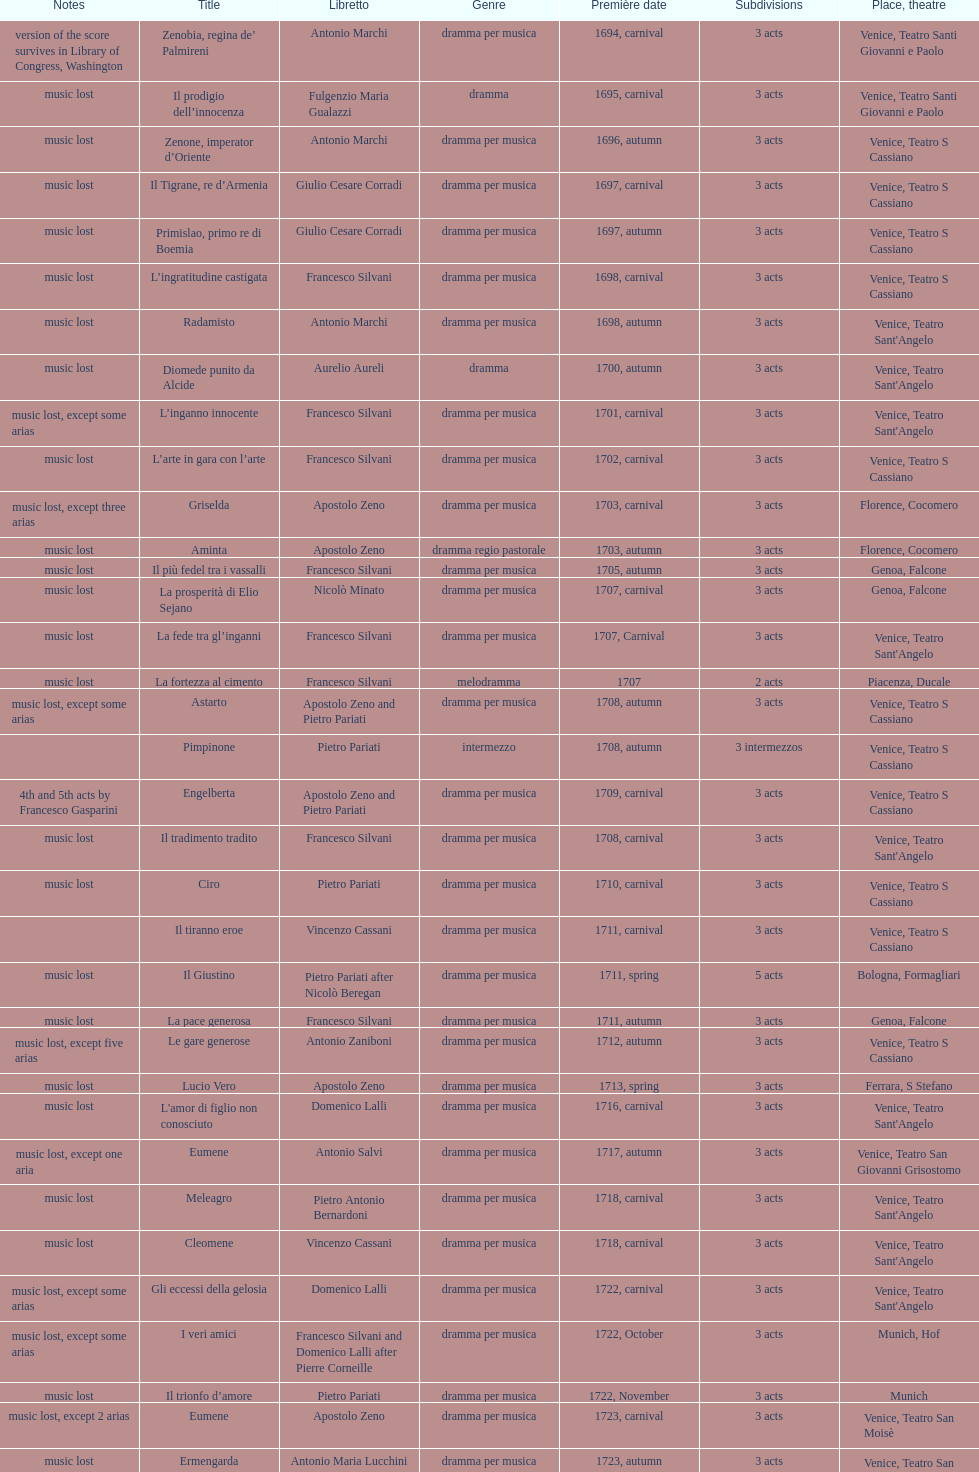I'm looking to parse the entire table for insights. Could you assist me with that? {'header': ['Notes', 'Title', 'Libretto', 'Genre', 'Première date', 'Sub\xaddivisions', 'Place, theatre'], 'rows': [['version of the score survives in Library of Congress, Washington', 'Zenobia, regina de’ Palmireni', 'Antonio Marchi', 'dramma per musica', '1694, carnival', '3 acts', 'Venice, Teatro Santi Giovanni e Paolo'], ['music lost', 'Il prodigio dell’innocenza', 'Fulgenzio Maria Gualazzi', 'dramma', '1695, carnival', '3 acts', 'Venice, Teatro Santi Giovanni e Paolo'], ['music lost', 'Zenone, imperator d’Oriente', 'Antonio Marchi', 'dramma per musica', '1696, autumn', '3 acts', 'Venice, Teatro S Cassiano'], ['music lost', 'Il Tigrane, re d’Armenia', 'Giulio Cesare Corradi', 'dramma per musica', '1697, carnival', '3 acts', 'Venice, Teatro S Cassiano'], ['music lost', 'Primislao, primo re di Boemia', 'Giulio Cesare Corradi', 'dramma per musica', '1697, autumn', '3 acts', 'Venice, Teatro S Cassiano'], ['music lost', 'L’ingratitudine castigata', 'Francesco Silvani', 'dramma per musica', '1698, carnival', '3 acts', 'Venice, Teatro S Cassiano'], ['music lost', 'Radamisto', 'Antonio Marchi', 'dramma per musica', '1698, autumn', '3 acts', "Venice, Teatro Sant'Angelo"], ['music lost', 'Diomede punito da Alcide', 'Aurelio Aureli', 'dramma', '1700, autumn', '3 acts', "Venice, Teatro Sant'Angelo"], ['music lost, except some arias', 'L’inganno innocente', 'Francesco Silvani', 'dramma per musica', '1701, carnival', '3 acts', "Venice, Teatro Sant'Angelo"], ['music lost', 'L’arte in gara con l’arte', 'Francesco Silvani', 'dramma per musica', '1702, carnival', '3 acts', 'Venice, Teatro S Cassiano'], ['music lost, except three arias', 'Griselda', 'Apostolo Zeno', 'dramma per musica', '1703, carnival', '3 acts', 'Florence, Cocomero'], ['music lost', 'Aminta', 'Apostolo Zeno', 'dramma regio pastorale', '1703, autumn', '3 acts', 'Florence, Cocomero'], ['music lost', 'Il più fedel tra i vassalli', 'Francesco Silvani', 'dramma per musica', '1705, autumn', '3 acts', 'Genoa, Falcone'], ['music lost', 'La prosperità di Elio Sejano', 'Nicolò Minato', 'dramma per musica', '1707, carnival', '3 acts', 'Genoa, Falcone'], ['music lost', 'La fede tra gl’inganni', 'Francesco Silvani', 'dramma per musica', '1707, Carnival', '3 acts', "Venice, Teatro Sant'Angelo"], ['music lost', 'La fortezza al cimento', 'Francesco Silvani', 'melodramma', '1707', '2 acts', 'Piacenza, Ducale'], ['music lost, except some arias', 'Astarto', 'Apostolo Zeno and Pietro Pariati', 'dramma per musica', '1708, autumn', '3 acts', 'Venice, Teatro S Cassiano'], ['', 'Pimpinone', 'Pietro Pariati', 'intermezzo', '1708, autumn', '3 intermezzos', 'Venice, Teatro S Cassiano'], ['4th and 5th acts by Francesco Gasparini', 'Engelberta', 'Apostolo Zeno and Pietro Pariati', 'dramma per musica', '1709, carnival', '3 acts', 'Venice, Teatro S Cassiano'], ['music lost', 'Il tradimento tradito', 'Francesco Silvani', 'dramma per musica', '1708, carnival', '3 acts', "Venice, Teatro Sant'Angelo"], ['music lost', 'Ciro', 'Pietro Pariati', 'dramma per musica', '1710, carnival', '3 acts', 'Venice, Teatro S Cassiano'], ['', 'Il tiranno eroe', 'Vincenzo Cassani', 'dramma per musica', '1711, carnival', '3 acts', 'Venice, Teatro S Cassiano'], ['music lost', 'Il Giustino', 'Pietro Pariati after Nicolò Beregan', 'dramma per musica', '1711, spring', '5 acts', 'Bologna, Formagliari'], ['music lost', 'La pace generosa', 'Francesco Silvani', 'dramma per musica', '1711, autumn', '3 acts', 'Genoa, Falcone'], ['music lost, except five arias', 'Le gare generose', 'Antonio Zaniboni', 'dramma per musica', '1712, autumn', '3 acts', 'Venice, Teatro S Cassiano'], ['music lost', 'Lucio Vero', 'Apostolo Zeno', 'dramma per musica', '1713, spring', '3 acts', 'Ferrara, S Stefano'], ['music lost', "L'amor di figlio non conosciuto", 'Domenico Lalli', 'dramma per musica', '1716, carnival', '3 acts', "Venice, Teatro Sant'Angelo"], ['music lost, except one aria', 'Eumene', 'Antonio Salvi', 'dramma per musica', '1717, autumn', '3 acts', 'Venice, Teatro San Giovanni Grisostomo'], ['music lost', 'Meleagro', 'Pietro Antonio Bernardoni', 'dramma per musica', '1718, carnival', '3 acts', "Venice, Teatro Sant'Angelo"], ['music lost', 'Cleomene', 'Vincenzo Cassani', 'dramma per musica', '1718, carnival', '3 acts', "Venice, Teatro Sant'Angelo"], ['music lost, except some arias', 'Gli eccessi della gelosia', 'Domenico Lalli', 'dramma per musica', '1722, carnival', '3 acts', "Venice, Teatro Sant'Angelo"], ['music lost, except some arias', 'I veri amici', 'Francesco Silvani and Domenico Lalli after Pierre Corneille', 'dramma per musica', '1722, October', '3 acts', 'Munich, Hof'], ['music lost', 'Il trionfo d’amore', 'Pietro Pariati', 'dramma per musica', '1722, November', '3 acts', 'Munich'], ['music lost, except 2 arias', 'Eumene', 'Apostolo Zeno', 'dramma per musica', '1723, carnival', '3 acts', 'Venice, Teatro San Moisè'], ['music lost', 'Ermengarda', 'Antonio Maria Lucchini', 'dramma per musica', '1723, autumn', '3 acts', 'Venice, Teatro San Moisè'], ['5th act by Giovanni Porta, music lost', 'Antigono, tutore di Filippo, re di Macedonia', 'Giovanni Piazzon', 'tragedia', '1724, carnival', '5 acts', 'Venice, Teatro San Moisè'], ['music lost', 'Scipione nelle Spagne', 'Apostolo Zeno', 'dramma per musica', '1724, Ascension', '3 acts', 'Venice, Teatro San Samuele'], ['music lost, except 2 arias', 'Laodice', 'Angelo Schietti', 'dramma per musica', '1724, autumn', '3 acts', 'Venice, Teatro San Moisè'], ['music lost', 'Didone abbandonata', 'Metastasio', 'tragedia', '1725, carnival', '3 acts', 'Venice, Teatro S Cassiano'], ['music lost', "L'impresario delle Isole Canarie", 'Metastasio', 'intermezzo', '1725, carnival', '2 acts', 'Venice, Teatro S Cassiano'], ['music lost', 'Alcina delusa da Ruggero', 'Antonio Marchi', 'dramma per musica', '1725, autumn', '3 acts', 'Venice, Teatro S Cassiano'], ['', 'I rivali generosi', 'Apostolo Zeno', 'dramma per musica', '1725', '3 acts', 'Brescia, Nuovo'], ['', 'La Statira', 'Apostolo Zeno and Pietro Pariati', 'dramma per musica', '1726, Carnival', '3 acts', 'Rome, Teatro Capranica'], ['', 'Malsazio e Fiammetta', '', 'intermezzo', '1726, Carnival', '', 'Rome, Teatro Capranica'], ['music lost', 'Il trionfo di Armida', 'Girolamo Colatelli after Torquato Tasso', 'dramma per musica', '1726, autumn', '3 acts', 'Venice, Teatro San Moisè'], ['music lost, except some arias', 'L’incostanza schernita', 'Vincenzo Cassani', 'dramma comico-pastorale', '1727, Ascension', '3 acts', 'Venice, Teatro San Samuele'], ['music lost', 'Le due rivali in amore', 'Aurelio Aureli', 'dramma per musica', '1728, autumn', '3 acts', 'Venice, Teatro San Moisè'], ['', 'Il Satrapone', 'Salvi', 'intermezzo', '1729', '', 'Parma, Omodeo'], ['music lost', 'Li stratagemmi amorosi', 'F Passerini', 'dramma per musica', '1730, carnival', '3 acts', 'Venice, Teatro San Moisè'], ['music lost', 'Elenia', 'Luisa Bergalli', 'dramma per musica', '1730, carnival', '3 acts', "Venice, Teatro Sant'Angelo"], ['mostly by Albinoni, music lost', 'Merope', 'Apostolo Zeno', 'dramma', '1731, autumn', '3 acts', 'Prague, Sporck Theater'], ['music lost', 'Il più infedel tra gli amanti', 'Angelo Schietti', 'dramma per musica', '1731, autumn', '3 acts', 'Treviso, Dolphin'], ['music lost, except five arias', 'Ardelinda', 'Bartolomeo Vitturi', 'dramma', '1732, autumn', '3 acts', "Venice, Teatro Sant'Angelo"], ['music lost', 'Candalide', 'Bartolomeo Vitturi', 'dramma per musica', '1734, carnival', '3 acts', "Venice, Teatro Sant'Angelo"], ['music lost', 'Artamene', 'Bartolomeo Vitturi', 'dramma per musica', '1741, carnival', '3 acts', "Venice, Teatro Sant'Angelo"]]} Which opera has at least 5 acts? Il Giustino. 